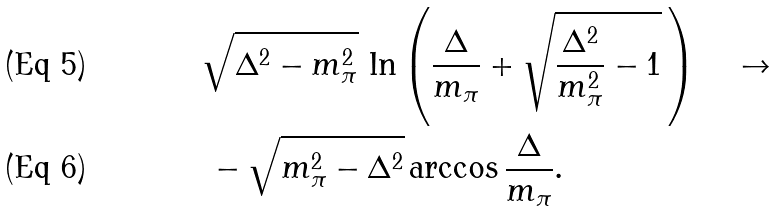<formula> <loc_0><loc_0><loc_500><loc_500>& \sqrt { \Delta ^ { 2 } - m _ { \pi } ^ { 2 } } \, \ln \left ( \frac { \Delta } { m _ { \pi } } + \sqrt { \frac { \Delta ^ { 2 } } { m _ { \pi } ^ { 2 } } - 1 } \, \right ) \quad \to \quad \\ & \, - \sqrt { m _ { \pi } ^ { 2 } - \Delta ^ { 2 } } \arccos \frac { \Delta } { m _ { \pi } } .</formula> 